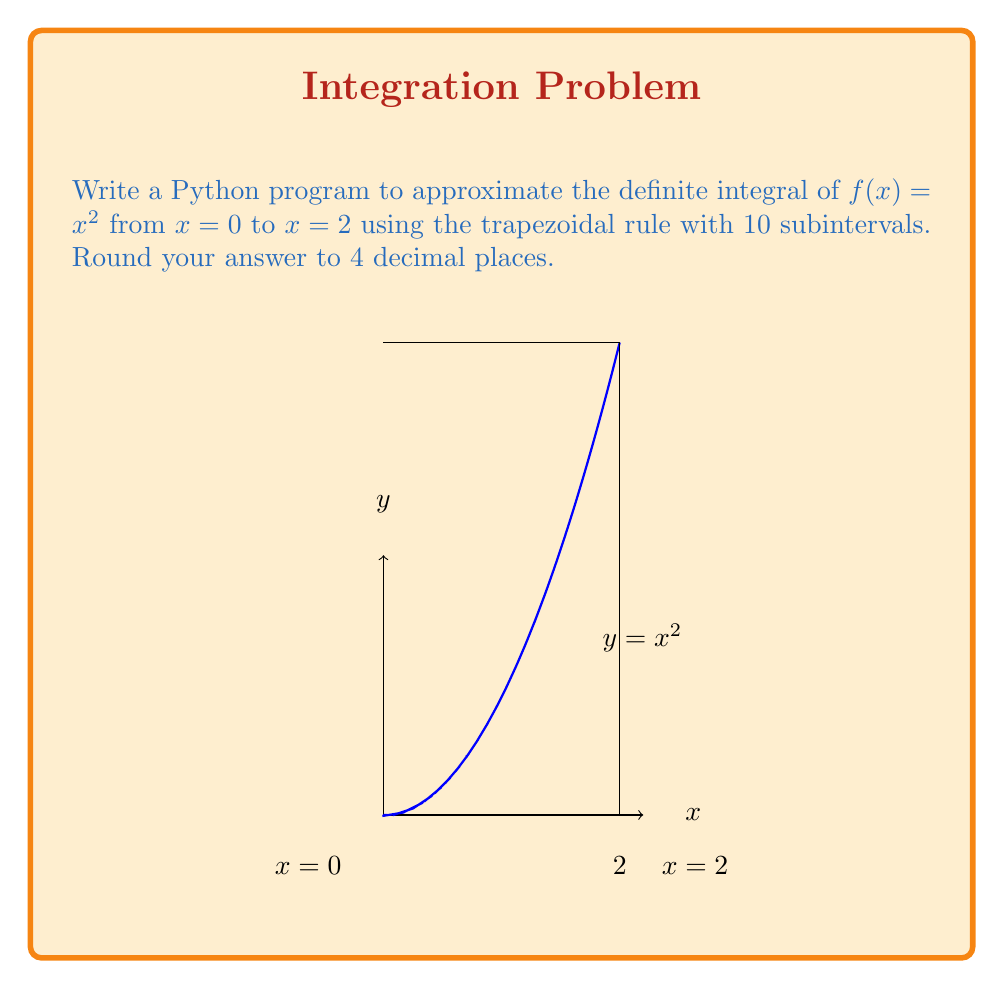Teach me how to tackle this problem. To approximate the definite integral using the trapezoidal rule with 10 subintervals:

1. The trapezoidal rule formula is:

   $$\int_a^b f(x)dx \approx \frac{h}{2}[f(x_0) + 2f(x_1) + 2f(x_2) + ... + 2f(x_{n-1}) + f(x_n)]$$

   where $h = \frac{b-a}{n}$, $n$ is the number of subintervals, and $x_i = a + ih$.

2. In this case, $a=0$, $b=2$, $n=10$, and $f(x) = x^2$.

3. Calculate $h$:
   $h = \frac{2-0}{10} = 0.2$

4. Generate $x_i$ values:
   $x_i = 0 + 0.2i$ for $i = 0, 1, ..., 10$

5. Evaluate $f(x_i)$ for each $x_i$.

6. Apply the trapezoidal rule:

   $$\int_0^2 x^2 dx \approx \frac{0.2}{2}[f(0) + 2f(0.2) + 2f(0.4) + ... + 2f(1.8) + f(2)]$$

7. Python code to implement this:

```python
def f(x):
    return x**2

a, b = 0, 2
n = 10
h = (b - a) / n

result = 0.5 * (f(a) + f(b))
for i in range(1, n):
    x = a + i * h
    result += f(x)

result *= h
print(round(result, 4))
```

8. Running this code gives the approximation 2.6560.

The exact value of the integral is $\frac{8}{3} \approx 2.6667$, so our approximation is quite close.
Answer: 2.6560 